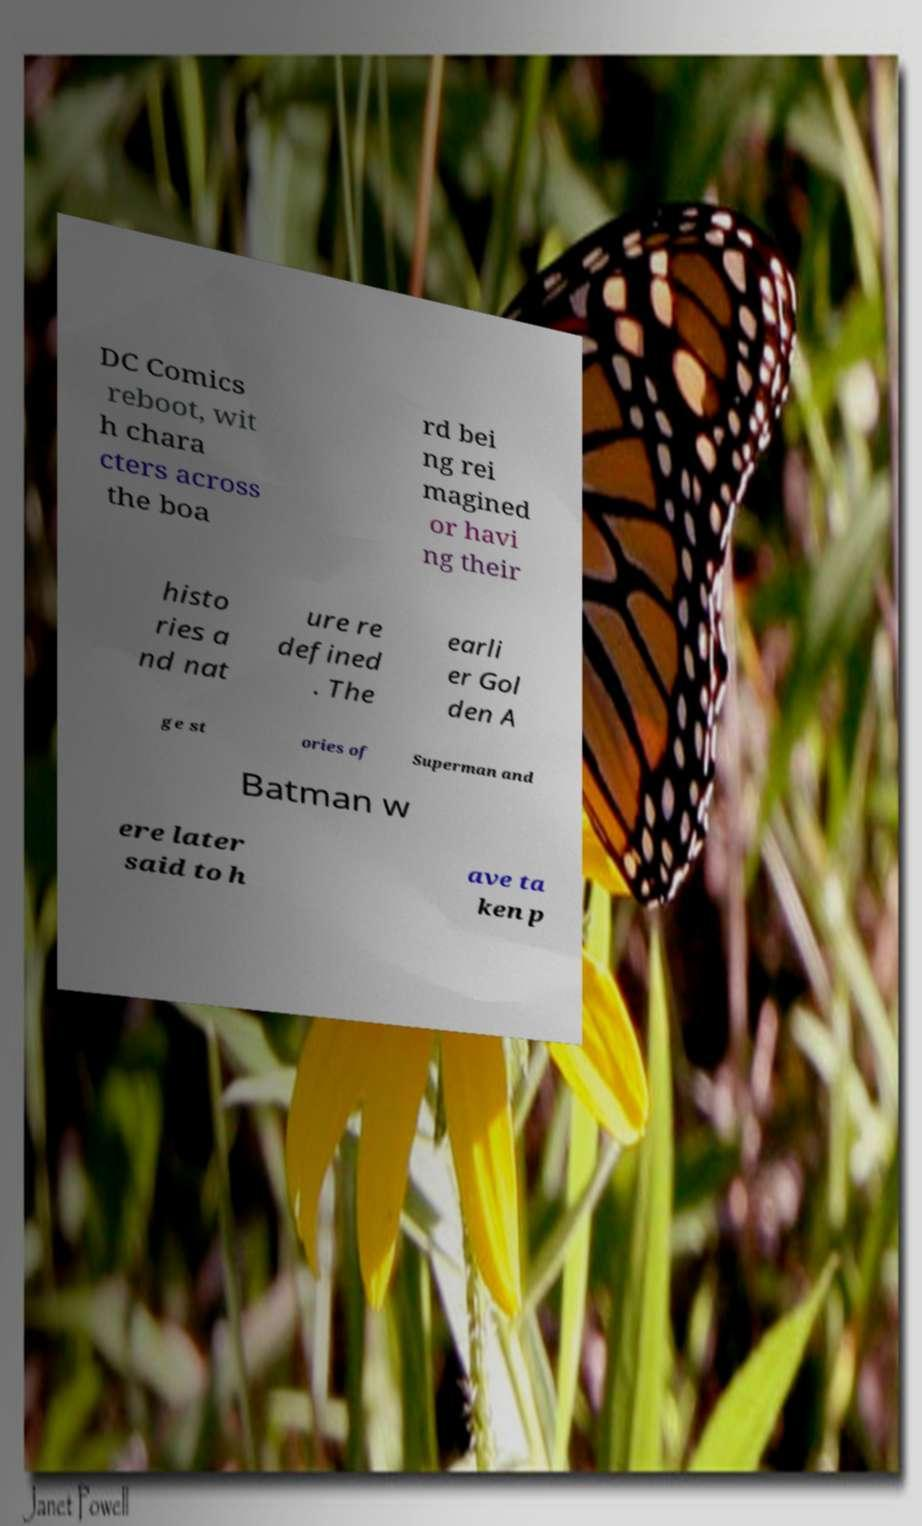There's text embedded in this image that I need extracted. Can you transcribe it verbatim? DC Comics reboot, wit h chara cters across the boa rd bei ng rei magined or havi ng their histo ries a nd nat ure re defined . The earli er Gol den A ge st ories of Superman and Batman w ere later said to h ave ta ken p 